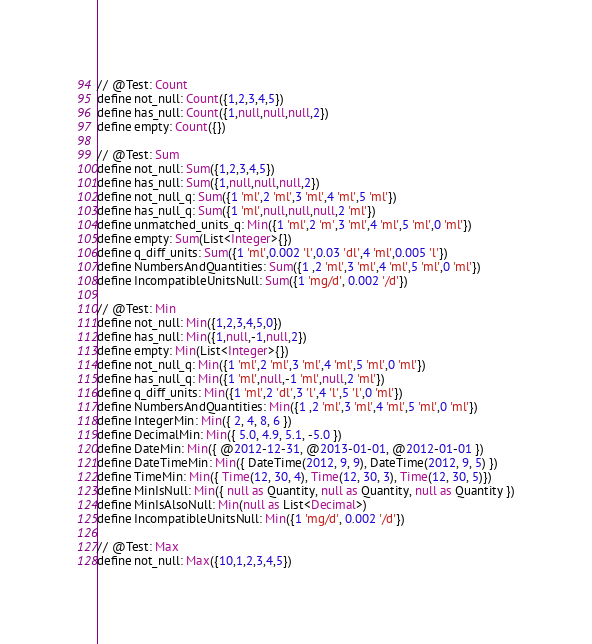Convert code to text. <code><loc_0><loc_0><loc_500><loc_500><_SQL_>// @Test: Count
define not_null: Count({1,2,3,4,5})
define has_null: Count({1,null,null,null,2})
define empty: Count({})

// @Test: Sum
define not_null: Sum({1,2,3,4,5})
define has_null: Sum({1,null,null,null,2})
define not_null_q: Sum({1 'ml',2 'ml',3 'ml',4 'ml',5 'ml'})
define has_null_q: Sum({1 'ml',null,null,null,2 'ml'})
define unmatched_units_q: Min({1 'ml',2 'm',3 'ml',4 'ml',5 'ml',0 'ml'})
define empty: Sum(List<Integer>{})
define q_diff_units: Sum({1 'ml',0.002 'l',0.03 'dl',4 'ml',0.005 'l'})
define NumbersAndQuantities: Sum({1 ,2 'ml',3 'ml',4 'ml',5 'ml',0 'ml'})
define IncompatibleUnitsNull: Sum({1 'mg/d', 0.002 '/d'})

// @Test: Min
define not_null: Min({1,2,3,4,5,0})
define has_null: Min({1,null,-1,null,2})
define empty: Min(List<Integer>{})
define not_null_q: Min({1 'ml',2 'ml',3 'ml',4 'ml',5 'ml',0 'ml'})
define has_null_q: Min({1 'ml',null,-1 'ml',null,2 'ml'})
define q_diff_units: Min({1 'ml',2 'dl',3 'l',4 'l',5 'l',0 'ml'})
define NumbersAndQuantities: Min({1 ,2 'ml',3 'ml',4 'ml',5 'ml',0 'ml'})
define IntegerMin: Min({ 2, 4, 8, 6 })
define DecimalMin: Min({ 5.0, 4.9, 5.1, -5.0 })
define DateMin: Min({ @2012-12-31, @2013-01-01, @2012-01-01 })
define DateTimeMin: Min({ DateTime(2012, 9, 9), DateTime(2012, 9, 5) })
define TimeMin: Min({ Time(12, 30, 4), Time(12, 30, 3), Time(12, 30, 5)})
define MinIsNull: Min({ null as Quantity, null as Quantity, null as Quantity })
define MinIsAlsoNull: Min(null as List<Decimal>)
define IncompatibleUnitsNull: Min({1 'mg/d', 0.002 '/d'})

// @Test: Max
define not_null: Max({10,1,2,3,4,5})</code> 